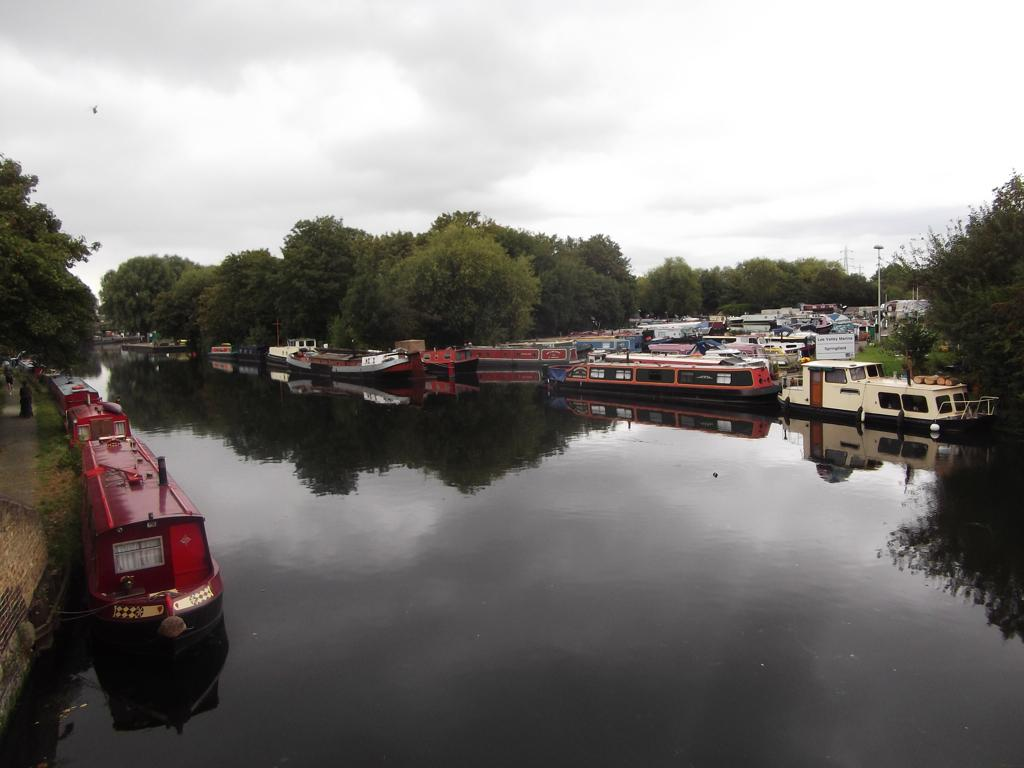What is located in the center of the image? There are boats in the water in the center of the image. What can be seen in the background of the image? The sky, clouds, and trees are visible in the background of the image. Are there any other boats visible in the image? Yes, there are additional boats in the background of the image. What thoughts or ideas are being expressed by the ghost in the image? There is no ghost present in the image, so it is not possible to answer that question. 